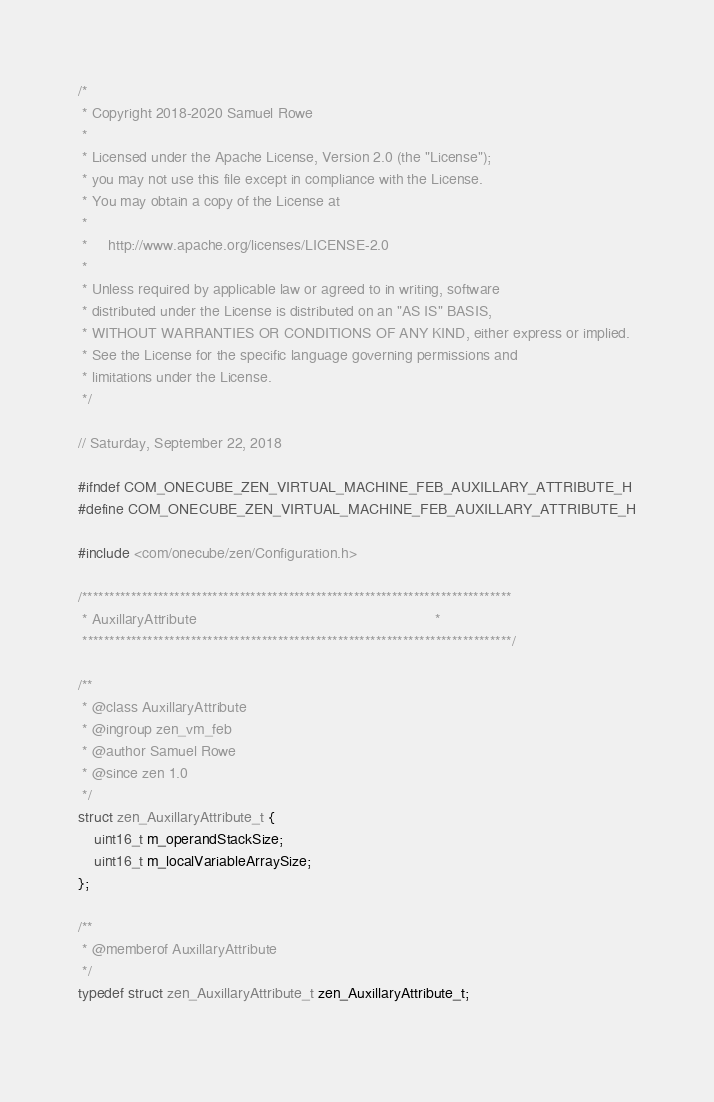Convert code to text. <code><loc_0><loc_0><loc_500><loc_500><_C_>/*
 * Copyright 2018-2020 Samuel Rowe
 * 
 * Licensed under the Apache License, Version 2.0 (the "License");
 * you may not use this file except in compliance with the License.
 * You may obtain a copy of the License at
 * 
 *     http://www.apache.org/licenses/LICENSE-2.0
 * 
 * Unless required by applicable law or agreed to in writing, software
 * distributed under the License is distributed on an "AS IS" BASIS,
 * WITHOUT WARRANTIES OR CONDITIONS OF ANY KIND, either express or implied.
 * See the License for the specific language governing permissions and
 * limitations under the License.
 */

// Saturday, September 22, 2018

#ifndef COM_ONECUBE_ZEN_VIRTUAL_MACHINE_FEB_AUXILLARY_ATTRIBUTE_H
#define COM_ONECUBE_ZEN_VIRTUAL_MACHINE_FEB_AUXILLARY_ATTRIBUTE_H

#include <com/onecube/zen/Configuration.h>

/*******************************************************************************
 * AuxillaryAttribute                                                          *
 *******************************************************************************/

/**
 * @class AuxillaryAttribute
 * @ingroup zen_vm_feb
 * @author Samuel Rowe
 * @since zen 1.0
 */
struct zen_AuxillaryAttribute_t {
    uint16_t m_operandStackSize;
    uint16_t m_localVariableArraySize;
};

/**
 * @memberof AuxillaryAttribute
 */
typedef struct zen_AuxillaryAttribute_t zen_AuxillaryAttribute_t;
    </code> 